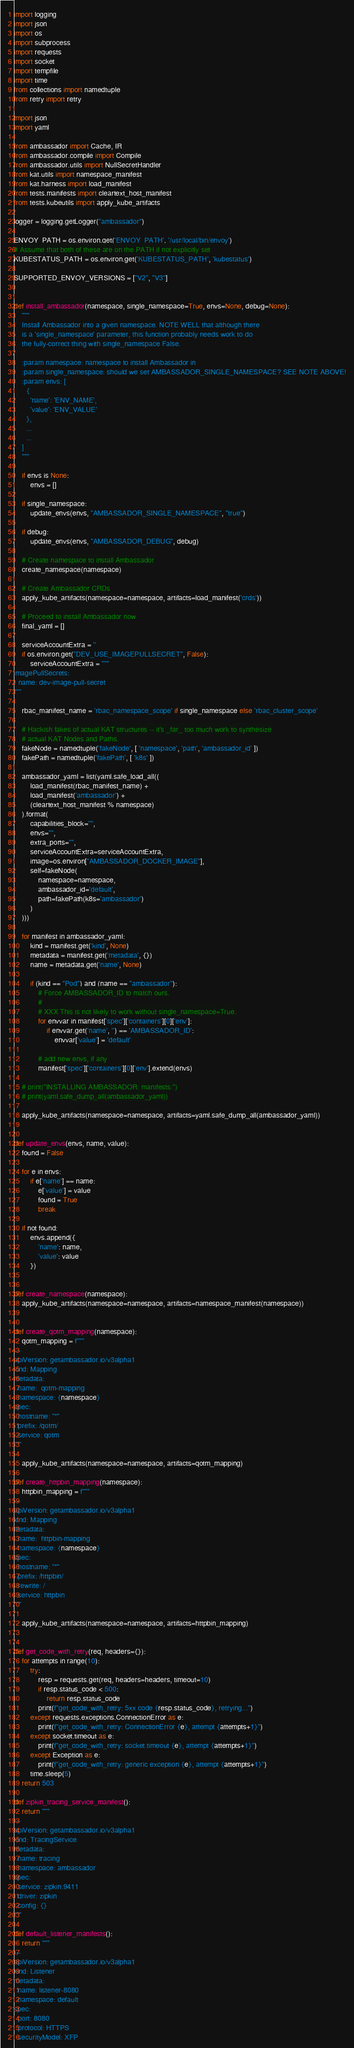<code> <loc_0><loc_0><loc_500><loc_500><_Python_>import logging
import json
import os
import subprocess
import requests
import socket
import tempfile
import time
from collections import namedtuple
from retry import retry

import json
import yaml

from ambassador import Cache, IR
from ambassador.compile import Compile
from ambassador.utils import NullSecretHandler
from kat.utils import namespace_manifest
from kat.harness import load_manifest
from tests.manifests import cleartext_host_manifest
from tests.kubeutils import apply_kube_artifacts

logger = logging.getLogger("ambassador")

ENVOY_PATH = os.environ.get('ENVOY_PATH', '/usr/local/bin/envoy')
# Assume that both of these are on the PATH if not explicitly set
KUBESTATUS_PATH = os.environ.get('KUBESTATUS_PATH', 'kubestatus')

SUPPORTED_ENVOY_VERSIONS = ["V2", "V3"]


def install_ambassador(namespace, single_namespace=True, envs=None, debug=None):
    """
    Install Ambassador into a given namespace. NOTE WELL that although there
    is a 'single_namespace' parameter, this function probably needs work to do
    the fully-correct thing with single_namespace False.

    :param namespace: namespace to install Ambassador in
    :param single_namespace: should we set AMBASSADOR_SINGLE_NAMESPACE? SEE NOTE ABOVE!
    :param envs: [
      {
        'name': 'ENV_NAME',
        'value': 'ENV_VALUE'
      },
      ...
      ...
    ]
    """

    if envs is None:
        envs = []

    if single_namespace:
        update_envs(envs, "AMBASSADOR_SINGLE_NAMESPACE", "true")

    if debug:
        update_envs(envs, "AMBASSADOR_DEBUG", debug)

    # Create namespace to install Ambassador
    create_namespace(namespace)

    # Create Ambassador CRDs
    apply_kube_artifacts(namespace=namespace, artifacts=load_manifest('crds'))

    # Proceed to install Ambassador now
    final_yaml = []

    serviceAccountExtra = ''
    if os.environ.get("DEV_USE_IMAGEPULLSECRET", False):
        serviceAccountExtra = """
imagePullSecrets:
- name: dev-image-pull-secret
"""

    rbac_manifest_name = 'rbac_namespace_scope' if single_namespace else 'rbac_cluster_scope'

    # Hackish fakes of actual KAT structures -- it's _far_ too much work to synthesize
    # actual KAT Nodes and Paths.
    fakeNode = namedtuple('fakeNode', [ 'namespace', 'path', 'ambassador_id' ])
    fakePath = namedtuple('fakePath', [ 'k8s' ])

    ambassador_yaml = list(yaml.safe_load_all((
        load_manifest(rbac_manifest_name) +
        load_manifest('ambassador') +
        (cleartext_host_manifest % namespace)
    ).format(
        capabilities_block="",
        envs="",
        extra_ports="",
        serviceAccountExtra=serviceAccountExtra,
        image=os.environ["AMBASSADOR_DOCKER_IMAGE"],
        self=fakeNode(
            namespace=namespace,
            ambassador_id='default',
            path=fakePath(k8s='ambassador')
        )
    )))

    for manifest in ambassador_yaml:
        kind = manifest.get('kind', None)
        metadata = manifest.get('metadata', {})
        name = metadata.get('name', None)

        if (kind == "Pod") and (name == "ambassador"):
            # Force AMBASSADOR_ID to match ours.
            #
            # XXX This is not likely to work without single_namespace=True.
            for envvar in manifest['spec']['containers'][0]['env']:
                if envvar.get('name', '') == 'AMBASSADOR_ID':
                    envvar['value'] = 'default'

            # add new envs, if any
            manifest['spec']['containers'][0]['env'].extend(envs)

    # print("INSTALLING AMBASSADOR: manifests:")
    # print(yaml.safe_dump_all(ambassador_yaml))

    apply_kube_artifacts(namespace=namespace, artifacts=yaml.safe_dump_all(ambassador_yaml))


def update_envs(envs, name, value):
    found = False

    for e in envs:
        if e['name'] == name:
            e['value'] = value
            found = True
            break

    if not found:
        envs.append({
            'name': name,
            'value': value
        })


def create_namespace(namespace):
    apply_kube_artifacts(namespace=namespace, artifacts=namespace_manifest(namespace))


def create_qotm_mapping(namespace):
    qotm_mapping = f"""
---
apiVersion: getambassador.io/v3alpha1
kind: Mapping
metadata:
  name:  qotm-mapping
  namespace: {namespace}
spec:
  hostname: "*"
  prefix: /qotm/
  service: qotm
"""

    apply_kube_artifacts(namespace=namespace, artifacts=qotm_mapping)

def create_httpbin_mapping(namespace):
    httpbin_mapping = f"""
---
apiVersion: getambassador.io/v3alpha1
kind: Mapping
metadata:
  name:  httpbin-mapping
  namespace: {namespace}
spec:
  hostname: "*"
  prefix: /httpbin/
  rewrite: /
  service: httpbin
"""

    apply_kube_artifacts(namespace=namespace, artifacts=httpbin_mapping)


def get_code_with_retry(req, headers={}):
    for attempts in range(10):
        try:
            resp = requests.get(req, headers=headers, timeout=10)
            if resp.status_code < 500:
                return resp.status_code
            print(f"get_code_with_retry: 5xx code {resp.status_code}, retrying...")
        except requests.exceptions.ConnectionError as e:
            print(f"get_code_with_retry: ConnectionError {e}, attempt {attempts+1}")
        except socket.timeout as e:
            print(f"get_code_with_retry: socket.timeout {e}, attempt {attempts+1}")
        except Exception as e:
            print(f"get_code_with_retry: generic exception {e}, attempt {attempts+1}")
        time.sleep(5)
    return 503

def zipkin_tracing_service_manifest():
    return """
---
apiVersion: getambassador.io/v3alpha1
kind: TracingService
metadata:
  name: tracing
  namespace: ambassador
spec:
  service: zipkin:9411
  driver: zipkin
  config: {}
"""

def default_listener_manifests():
    return """
---
apiVersion: getambassador.io/v3alpha1
kind: Listener
metadata:
  name: listener-8080
  namespace: default
spec:
  port: 8080
  protocol: HTTPS
  securityModel: XFP</code> 